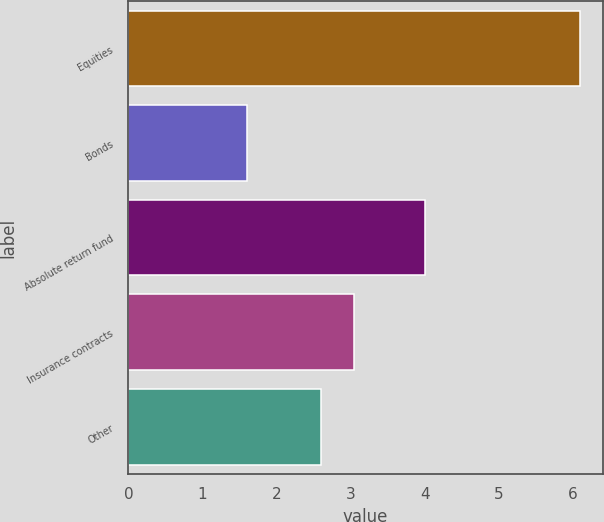<chart> <loc_0><loc_0><loc_500><loc_500><bar_chart><fcel>Equities<fcel>Bonds<fcel>Absolute return fund<fcel>Insurance contracts<fcel>Other<nl><fcel>6.1<fcel>1.6<fcel>4<fcel>3.05<fcel>2.6<nl></chart> 